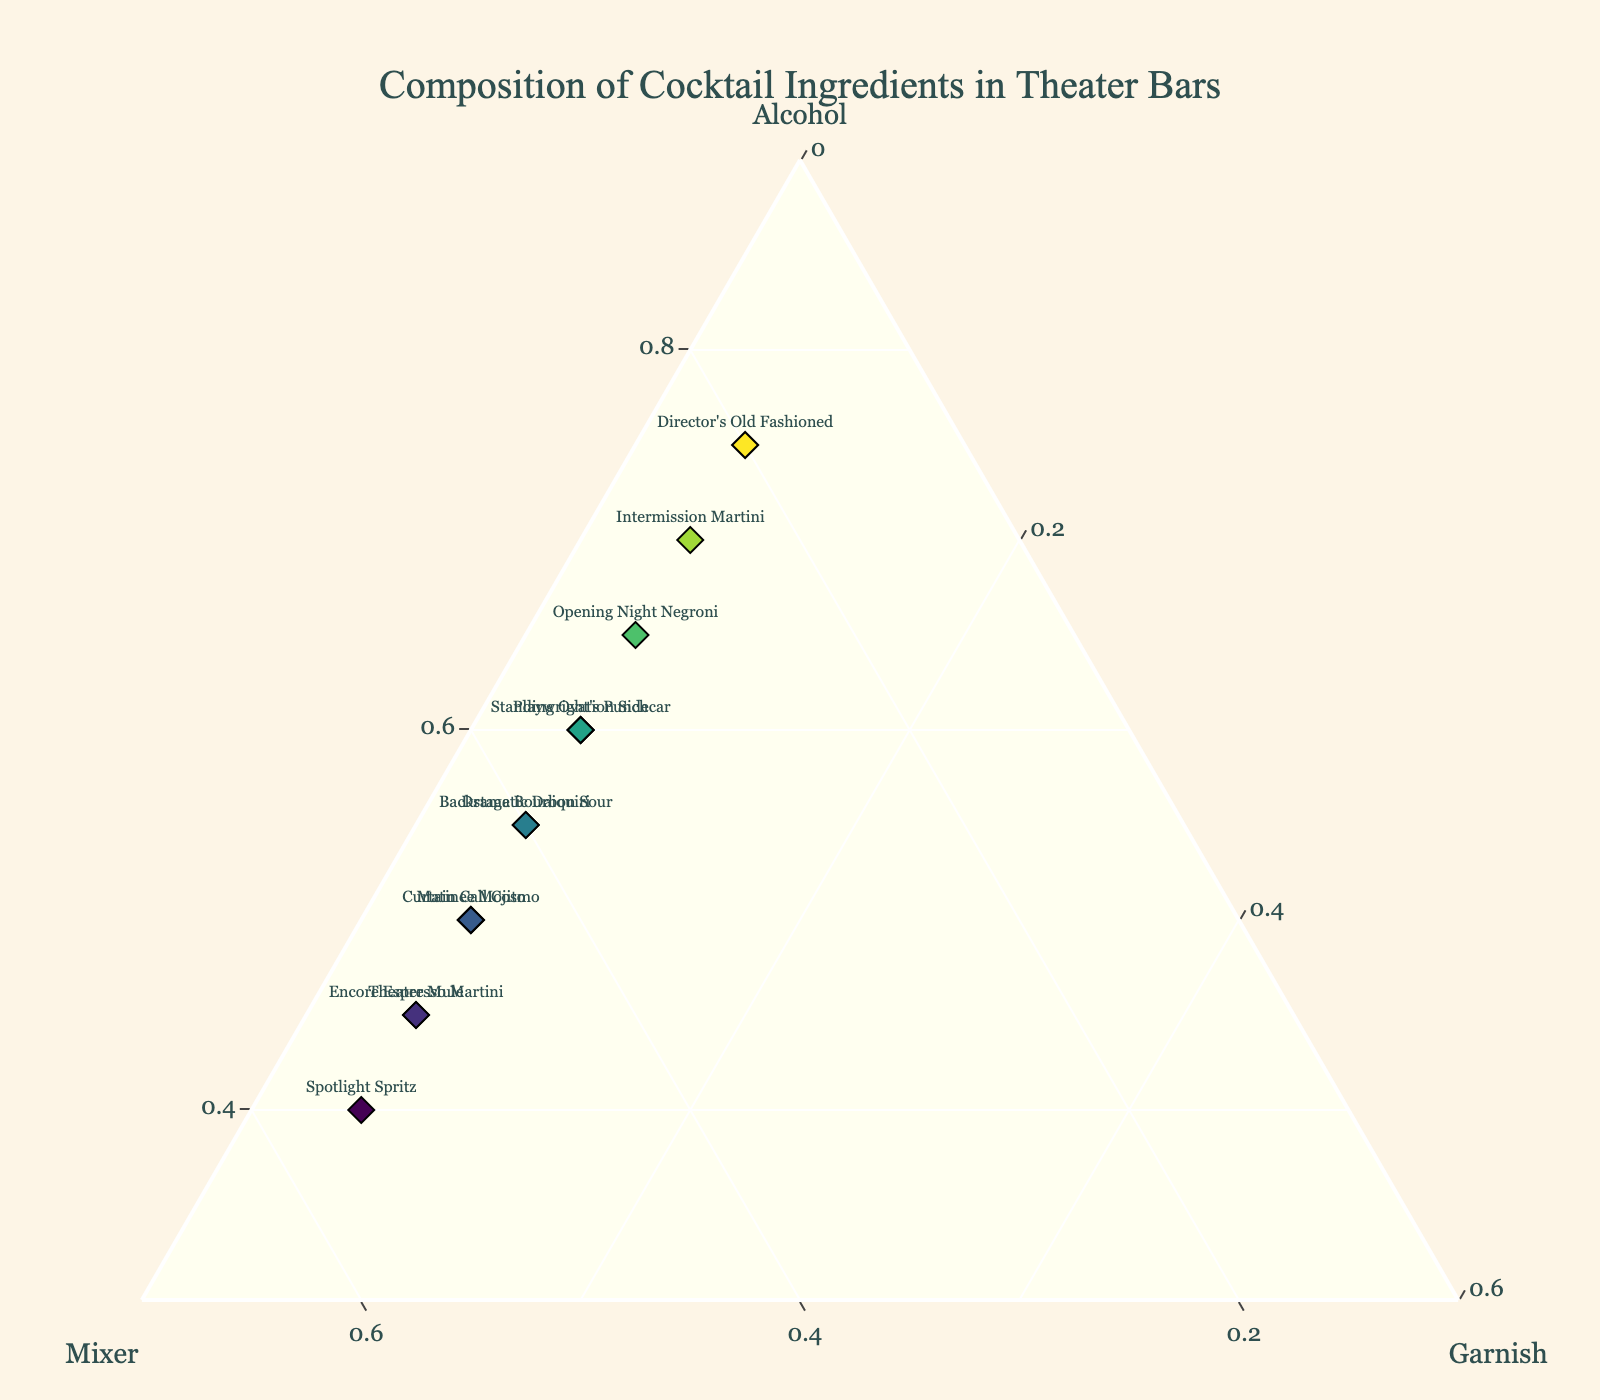What is the title of the plot? The title is prominently displayed at the top of the plot, indicating the main subject of the visualization. It reads "Composition of Cocktail Ingredients in Theater Bars."
Answer: Composition of Cocktail Ingredients in Theater Bars Which cocktail has the highest proportion of alcohol? By examining the ternary plot, the cocktail with the highest proportion of alcohol will be located closest to the "Alcohol" axis. "Director's Old Fashioned" appears closest to this axis, indicating that it has the highest alcohol content.
Answer: Director's Old Fashioned Which cocktail is composed of equal parts mixer and alcohol? To find this, look for a point that is equally distant from both the "Mixer" and "Alcohol" axes on the ternary plot. The "Curtain Call Cosmo" and "Matinee Mojito" both have nearly equal values of 50/45 for Alcohol/Mixer, but the question is about exactly equal parts. None exactly match 1:1, so the closest needs to be identified.
Answer: Curtain Call Cosmo (closest match) What is the median value of the alcohol content in the listed cocktails? List the alcohol content values: 40, 45, 45, 50, 50, 55, 55, 55, 60, 60, 65, 70, 75. Since there are 12 data points, the median will be the average of the 6th and 7th values when sorted. (55+55)/2 = 55.
Answer: 55 Which cocktail is closest to a 50:50:0 ratio of alcohol, mixer, and garnish? This type of cocktail will be located near the middle of the triangle closer to the alcohol/mixer line, since it's 50:50 for these two components. The one closest to this description is the "Curtain Call Cosmo."
Answer: Curtain Call Cosmo Which cocktail locations are furthest apart on the plot? Look for the two points that have the greatest distance between them. Visually, "Director's Old Fashioned" and "Spotlight Spritz" appear to be the furthest apart, as one is near the Alcohol axis and the other near the Mixer axis.
Answer: Director's Old Fashioned and Spotlight Spritz How many cocktails have more than 60% alcohol content? Identify the data points that lie closest to the "Alcohol" vertex of the ternary plot. The cocktails are "Playwright's Punch," "Opening Night Negroni," "Director's Old Fashioned," and "Intermission Martini."
Answer: 4 Which cocktail has the lowest proportion of mixer? Look at which point is closest to the "Mixer" axis but far from the "Mixer" vertex. "Director's Old Fashioned" has the lowest proportion of mixer, at 20%.
Answer: Director's Old Fashioned What is the combined percentage of mixer and garnish in "Spotlight Spritz"? For this cocktail, the mixer is 55% and the garnish is 5%. Adding these together: 55% + 5% = 60%.
Answer: 60% 